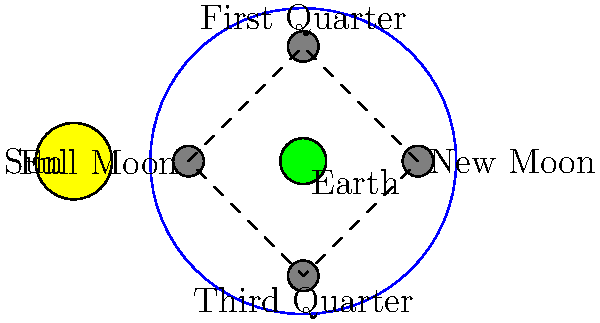As an entrepreneur developing an AI-powered baking robot, you're discussing the concept of cycles with your grandmother. To draw a parallel between baking cycles and natural phenomena, you bring up the Moon's phases. In the diagram, which phase of the Moon would result in the most sunlight reflected towards Earth, potentially inspiring a "Full Moon" themed pastry for your robot to create? Let's analyze the Moon's phases step-by-step:

1. The diagram shows the Sun, Earth, and four positions of the Moon in its orbit around Earth.

2. The Moon's phases are determined by the amount of its illuminated surface visible from Earth.

3. New Moon (rightmost position):
   - The Moon is between the Sun and Earth.
   - Its dark side faces Earth, reflecting no sunlight.

4. First Quarter (top position):
   - Half of the Moon's Earth-facing side is illuminated.
   - We see a "half moon" from Earth.

5. Full Moon (leftmost position):
   - The Earth is between the Sun and Moon.
   - The entire Earth-facing side of the Moon is illuminated.
   - This phase reflects the most sunlight towards Earth.

6. Third Quarter (bottom position):
   - Similar to First Quarter, but the other half is illuminated.
   - We see a "half moon" from Earth, but opposite to First Quarter.

The Full Moon phase, when the Moon is on the opposite side of Earth from the Sun, reflects the most sunlight towards Earth. This would be the ideal inspiration for a "Full Moon" themed pastry, as it represents the brightest and most visible lunar phase.
Answer: Full Moon 